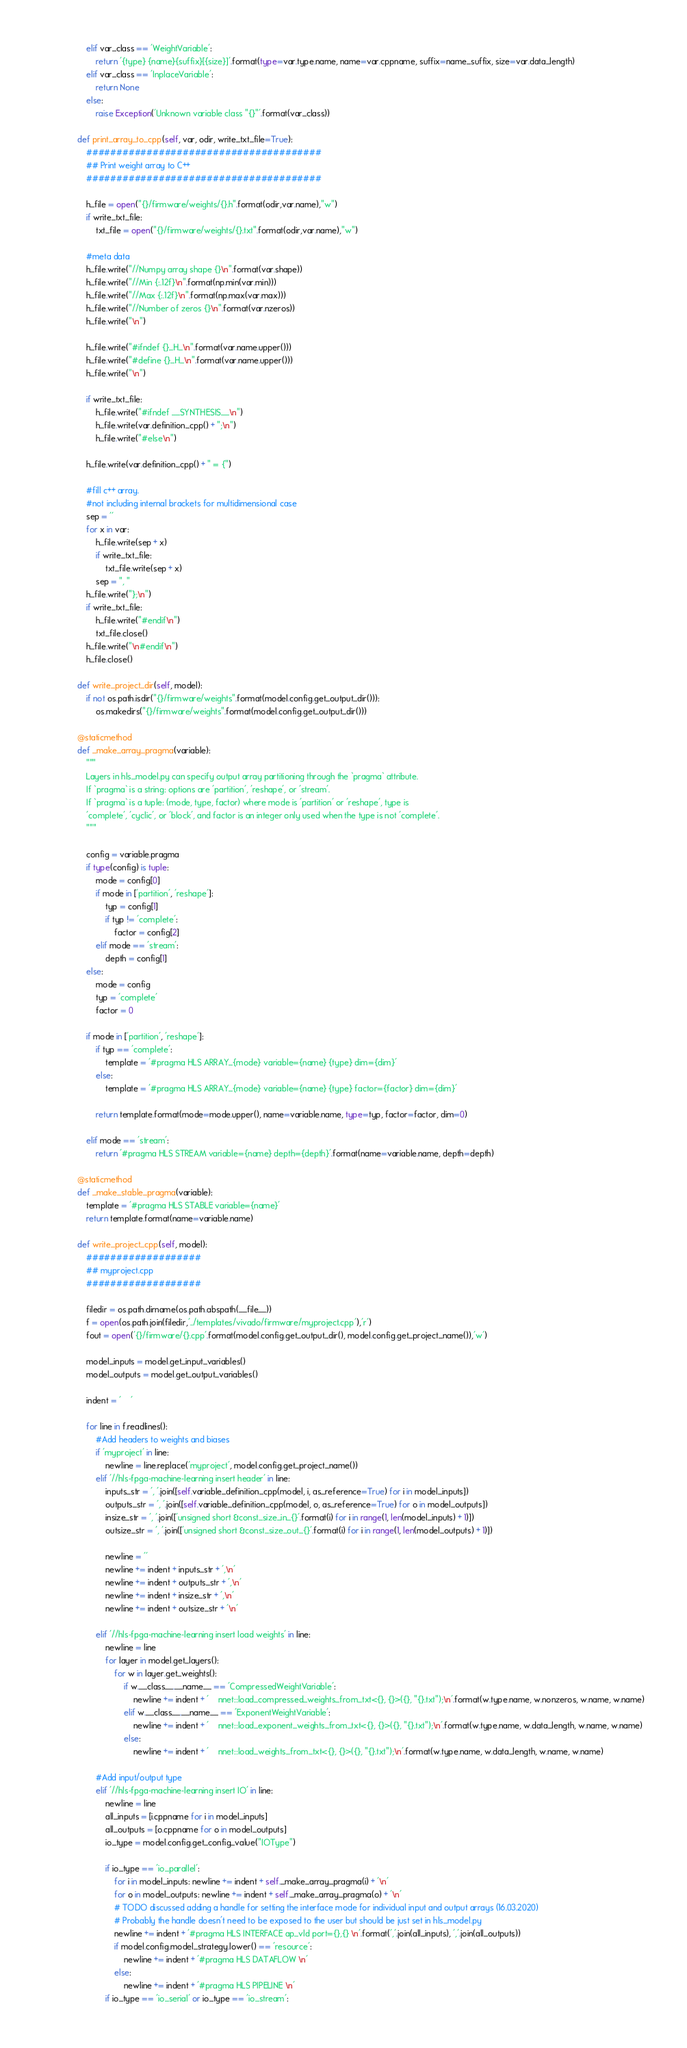Convert code to text. <code><loc_0><loc_0><loc_500><loc_500><_Python_>        elif var_class == 'WeightVariable':
            return '{type} {name}{suffix}[{size}]'.format(type=var.type.name, name=var.cppname, suffix=name_suffix, size=var.data_length)
        elif var_class == 'InplaceVariable':
            return None
        else:
            raise Exception('Unknown variable class "{}"'.format(var_class))

    def print_array_to_cpp(self, var, odir, write_txt_file=True):
        #######################################
        ## Print weight array to C++
        #######################################

        h_file = open("{}/firmware/weights/{}.h".format(odir,var.name),"w")
        if write_txt_file:
            txt_file = open("{}/firmware/weights/{}.txt".format(odir,var.name),"w")

        #meta data
        h_file.write("//Numpy array shape {}\n".format(var.shape))
        h_file.write("//Min {:.12f}\n".format(np.min(var.min)))
        h_file.write("//Max {:.12f}\n".format(np.max(var.max)))
        h_file.write("//Number of zeros {}\n".format(var.nzeros))
        h_file.write("\n")

        h_file.write("#ifndef {}_H_\n".format(var.name.upper()))
        h_file.write("#define {}_H_\n".format(var.name.upper()))
        h_file.write("\n")

        if write_txt_file:
            h_file.write("#ifndef __SYNTHESIS__\n")
            h_file.write(var.definition_cpp() + ";\n")
            h_file.write("#else\n")

        h_file.write(var.definition_cpp() + " = {")

        #fill c++ array.
        #not including internal brackets for multidimensional case
        sep = ''
        for x in var:
            h_file.write(sep + x)
            if write_txt_file:
                txt_file.write(sep + x)
            sep = ", "
        h_file.write("};\n")
        if write_txt_file:
            h_file.write("#endif\n")
            txt_file.close()
        h_file.write("\n#endif\n")
        h_file.close()

    def write_project_dir(self, model):
        if not os.path.isdir("{}/firmware/weights".format(model.config.get_output_dir())):
            os.makedirs("{}/firmware/weights".format(model.config.get_output_dir()))

    @staticmethod
    def _make_array_pragma(variable):
        """
        Layers in hls_model.py can specify output array partitioning through the `pragma` attribute.
        If `pragma` is a string: options are 'partition', 'reshape', or 'stream'.
        If `pragma` is a tuple: (mode, type, factor) where mode is 'partition' or 'reshape', type is
        'complete', 'cyclic', or 'block', and factor is an integer only used when the type is not 'complete'.
        """
        
        config = variable.pragma
        if type(config) is tuple:
            mode = config[0]
            if mode in ['partition', 'reshape']:
                typ = config[1]
                if typ != 'complete':
                    factor = config[2]
            elif mode == 'stream':
                depth = config[1]
        else:
            mode = config
            typ = 'complete'
            factor = 0

        if mode in ['partition', 'reshape']:
            if typ == 'complete':
                template = '#pragma HLS ARRAY_{mode} variable={name} {type} dim={dim}'
            else:
                template = '#pragma HLS ARRAY_{mode} variable={name} {type} factor={factor} dim={dim}'

            return template.format(mode=mode.upper(), name=variable.name, type=typ, factor=factor, dim=0)

        elif mode == 'stream':
            return '#pragma HLS STREAM variable={name} depth={depth}'.format(name=variable.name, depth=depth)

    @staticmethod
    def _make_stable_pragma(variable):
        template = '#pragma HLS STABLE variable={name}'
        return template.format(name=variable.name)

    def write_project_cpp(self, model):
        ###################
        ## myproject.cpp
        ###################

        filedir = os.path.dirname(os.path.abspath(__file__))
        f = open(os.path.join(filedir,'../templates/vivado/firmware/myproject.cpp'),'r')
        fout = open('{}/firmware/{}.cpp'.format(model.config.get_output_dir(), model.config.get_project_name()),'w')

        model_inputs = model.get_input_variables()
        model_outputs = model.get_output_variables()

        indent = '    '

        for line in f.readlines():
            #Add headers to weights and biases
            if 'myproject' in line:
                newline = line.replace('myproject', model.config.get_project_name())
            elif '//hls-fpga-machine-learning insert header' in line:
                inputs_str = ', '.join([self.variable_definition_cpp(model, i, as_reference=True) for i in model_inputs])
                outputs_str = ', '.join([self.variable_definition_cpp(model, o, as_reference=True) for o in model_outputs])
                insize_str = ', '.join(['unsigned short &const_size_in_{}'.format(i) for i in range(1, len(model_inputs) + 1)])
                outsize_str = ', '.join(['unsigned short &const_size_out_{}'.format(i) for i in range(1, len(model_outputs) + 1)])

                newline = ''
                newline += indent + inputs_str + ',\n'
                newline += indent + outputs_str + ',\n'
                newline += indent + insize_str + ',\n'
                newline += indent + outsize_str + '\n'

            elif '//hls-fpga-machine-learning insert load weights' in line:
                newline = line
                for layer in model.get_layers():
                    for w in layer.get_weights():
                        if w.__class__.__name__ == 'CompressedWeightVariable':
                            newline += indent + '    nnet::load_compressed_weights_from_txt<{}, {}>({}, "{}.txt");\n'.format(w.type.name, w.nonzeros, w.name, w.name)
                        elif w.__class__.__name__ == 'ExponentWeightVariable':
                            newline += indent + '    nnet::load_exponent_weights_from_txt<{}, {}>({}, "{}.txt");\n'.format(w.type.name, w.data_length, w.name, w.name)
                        else:
                            newline += indent + '    nnet::load_weights_from_txt<{}, {}>({}, "{}.txt");\n'.format(w.type.name, w.data_length, w.name, w.name)

            #Add input/output type
            elif '//hls-fpga-machine-learning insert IO' in line:
                newline = line
                all_inputs = [i.cppname for i in model_inputs]
                all_outputs = [o.cppname for o in model_outputs]
                io_type = model.config.get_config_value("IOType")

                if io_type == 'io_parallel':
                    for i in model_inputs: newline += indent + self._make_array_pragma(i) + '\n'
                    for o in model_outputs: newline += indent + self._make_array_pragma(o) + '\n'
                    # TODO discussed adding a handle for setting the interface mode for individual input and output arrays (16.03.2020)
                    # Probably the handle doesn't need to be exposed to the user but should be just set in hls_model.py
                    newline += indent + '#pragma HLS INTERFACE ap_vld port={},{} \n'.format(','.join(all_inputs), ','.join(all_outputs))
                    if model.config.model_strategy.lower() == 'resource':
                        newline += indent + '#pragma HLS DATAFLOW \n'
                    else:
                        newline += indent + '#pragma HLS PIPELINE \n'
                if io_type == 'io_serial' or io_type == 'io_stream':</code> 